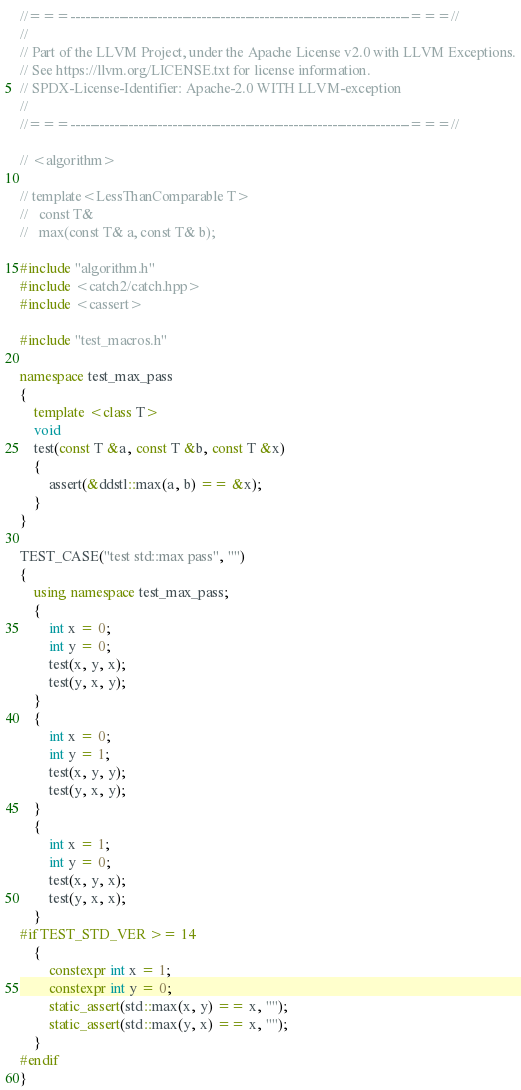Convert code to text. <code><loc_0><loc_0><loc_500><loc_500><_C++_>//===----------------------------------------------------------------------===//
//
// Part of the LLVM Project, under the Apache License v2.0 with LLVM Exceptions.
// See https://llvm.org/LICENSE.txt for license information.
// SPDX-License-Identifier: Apache-2.0 WITH LLVM-exception
//
//===----------------------------------------------------------------------===//

// <algorithm>

// template<LessThanComparable T>
//   const T&
//   max(const T& a, const T& b);

#include "algorithm.h"
#include <catch2/catch.hpp>
#include <cassert>

#include "test_macros.h"

namespace test_max_pass
{
    template <class T>
    void
    test(const T &a, const T &b, const T &x)
    {
        assert(&ddstl::max(a, b) == &x);
    }
}

TEST_CASE("test std::max pass", "")
{
    using namespace test_max_pass;
    {
        int x = 0;
        int y = 0;
        test(x, y, x);
        test(y, x, y);
    }
    {
        int x = 0;
        int y = 1;
        test(x, y, y);
        test(y, x, y);
    }
    {
        int x = 1;
        int y = 0;
        test(x, y, x);
        test(y, x, x);
    }
#if TEST_STD_VER >= 14
    {
        constexpr int x = 1;
        constexpr int y = 0;
        static_assert(std::max(x, y) == x, "");
        static_assert(std::max(y, x) == x, "");
    }
#endif
}</code> 